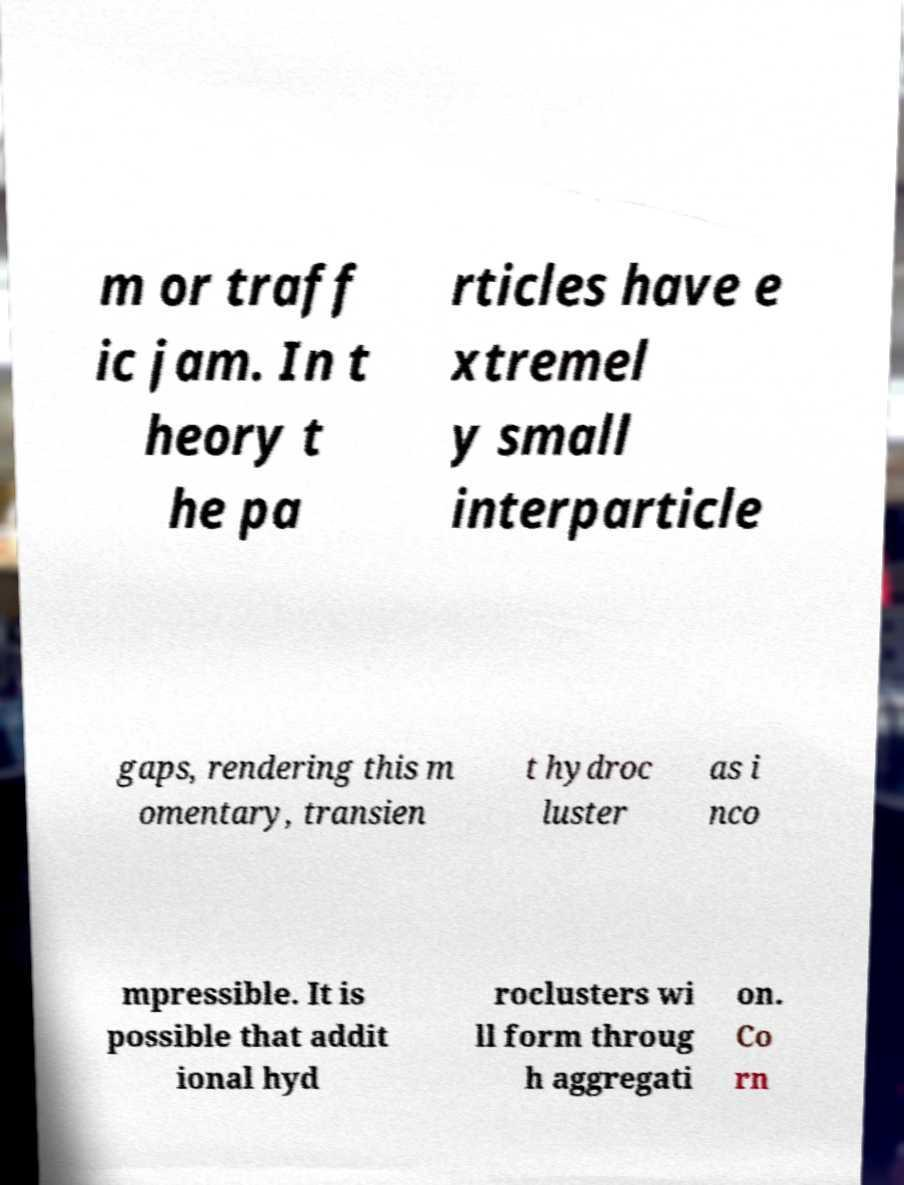Can you read and provide the text displayed in the image?This photo seems to have some interesting text. Can you extract and type it out for me? m or traff ic jam. In t heory t he pa rticles have e xtremel y small interparticle gaps, rendering this m omentary, transien t hydroc luster as i nco mpressible. It is possible that addit ional hyd roclusters wi ll form throug h aggregati on. Co rn 